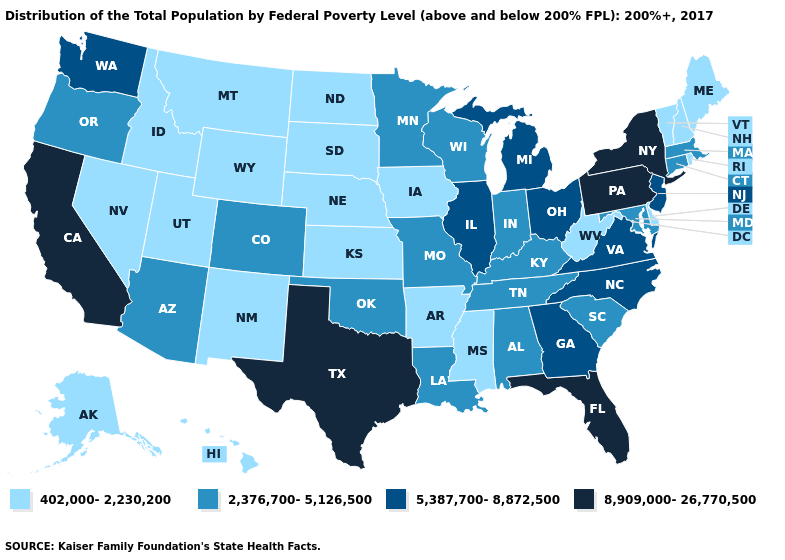Name the states that have a value in the range 2,376,700-5,126,500?
Be succinct. Alabama, Arizona, Colorado, Connecticut, Indiana, Kentucky, Louisiana, Maryland, Massachusetts, Minnesota, Missouri, Oklahoma, Oregon, South Carolina, Tennessee, Wisconsin. What is the highest value in states that border Indiana?
Keep it brief. 5,387,700-8,872,500. Among the states that border Mississippi , which have the lowest value?
Keep it brief. Arkansas. Name the states that have a value in the range 402,000-2,230,200?
Concise answer only. Alaska, Arkansas, Delaware, Hawaii, Idaho, Iowa, Kansas, Maine, Mississippi, Montana, Nebraska, Nevada, New Hampshire, New Mexico, North Dakota, Rhode Island, South Dakota, Utah, Vermont, West Virginia, Wyoming. Does Mississippi have a lower value than Arizona?
Answer briefly. Yes. Name the states that have a value in the range 8,909,000-26,770,500?
Give a very brief answer. California, Florida, New York, Pennsylvania, Texas. Name the states that have a value in the range 2,376,700-5,126,500?
Quick response, please. Alabama, Arizona, Colorado, Connecticut, Indiana, Kentucky, Louisiana, Maryland, Massachusetts, Minnesota, Missouri, Oklahoma, Oregon, South Carolina, Tennessee, Wisconsin. Which states have the lowest value in the Northeast?
Give a very brief answer. Maine, New Hampshire, Rhode Island, Vermont. Which states have the lowest value in the South?
Concise answer only. Arkansas, Delaware, Mississippi, West Virginia. Does the first symbol in the legend represent the smallest category?
Write a very short answer. Yes. Among the states that border Idaho , does Utah have the highest value?
Short answer required. No. Name the states that have a value in the range 402,000-2,230,200?
Concise answer only. Alaska, Arkansas, Delaware, Hawaii, Idaho, Iowa, Kansas, Maine, Mississippi, Montana, Nebraska, Nevada, New Hampshire, New Mexico, North Dakota, Rhode Island, South Dakota, Utah, Vermont, West Virginia, Wyoming. Name the states that have a value in the range 5,387,700-8,872,500?
Answer briefly. Georgia, Illinois, Michigan, New Jersey, North Carolina, Ohio, Virginia, Washington. Name the states that have a value in the range 8,909,000-26,770,500?
Answer briefly. California, Florida, New York, Pennsylvania, Texas. 